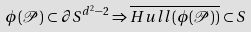Convert formula to latex. <formula><loc_0><loc_0><loc_500><loc_500>\phi ( \mathcal { P } ) \subset \partial S ^ { d ^ { 2 } - 2 } \Rightarrow \overline { H u l l ( \phi ( \mathcal { P } ) ) } \subset S</formula> 